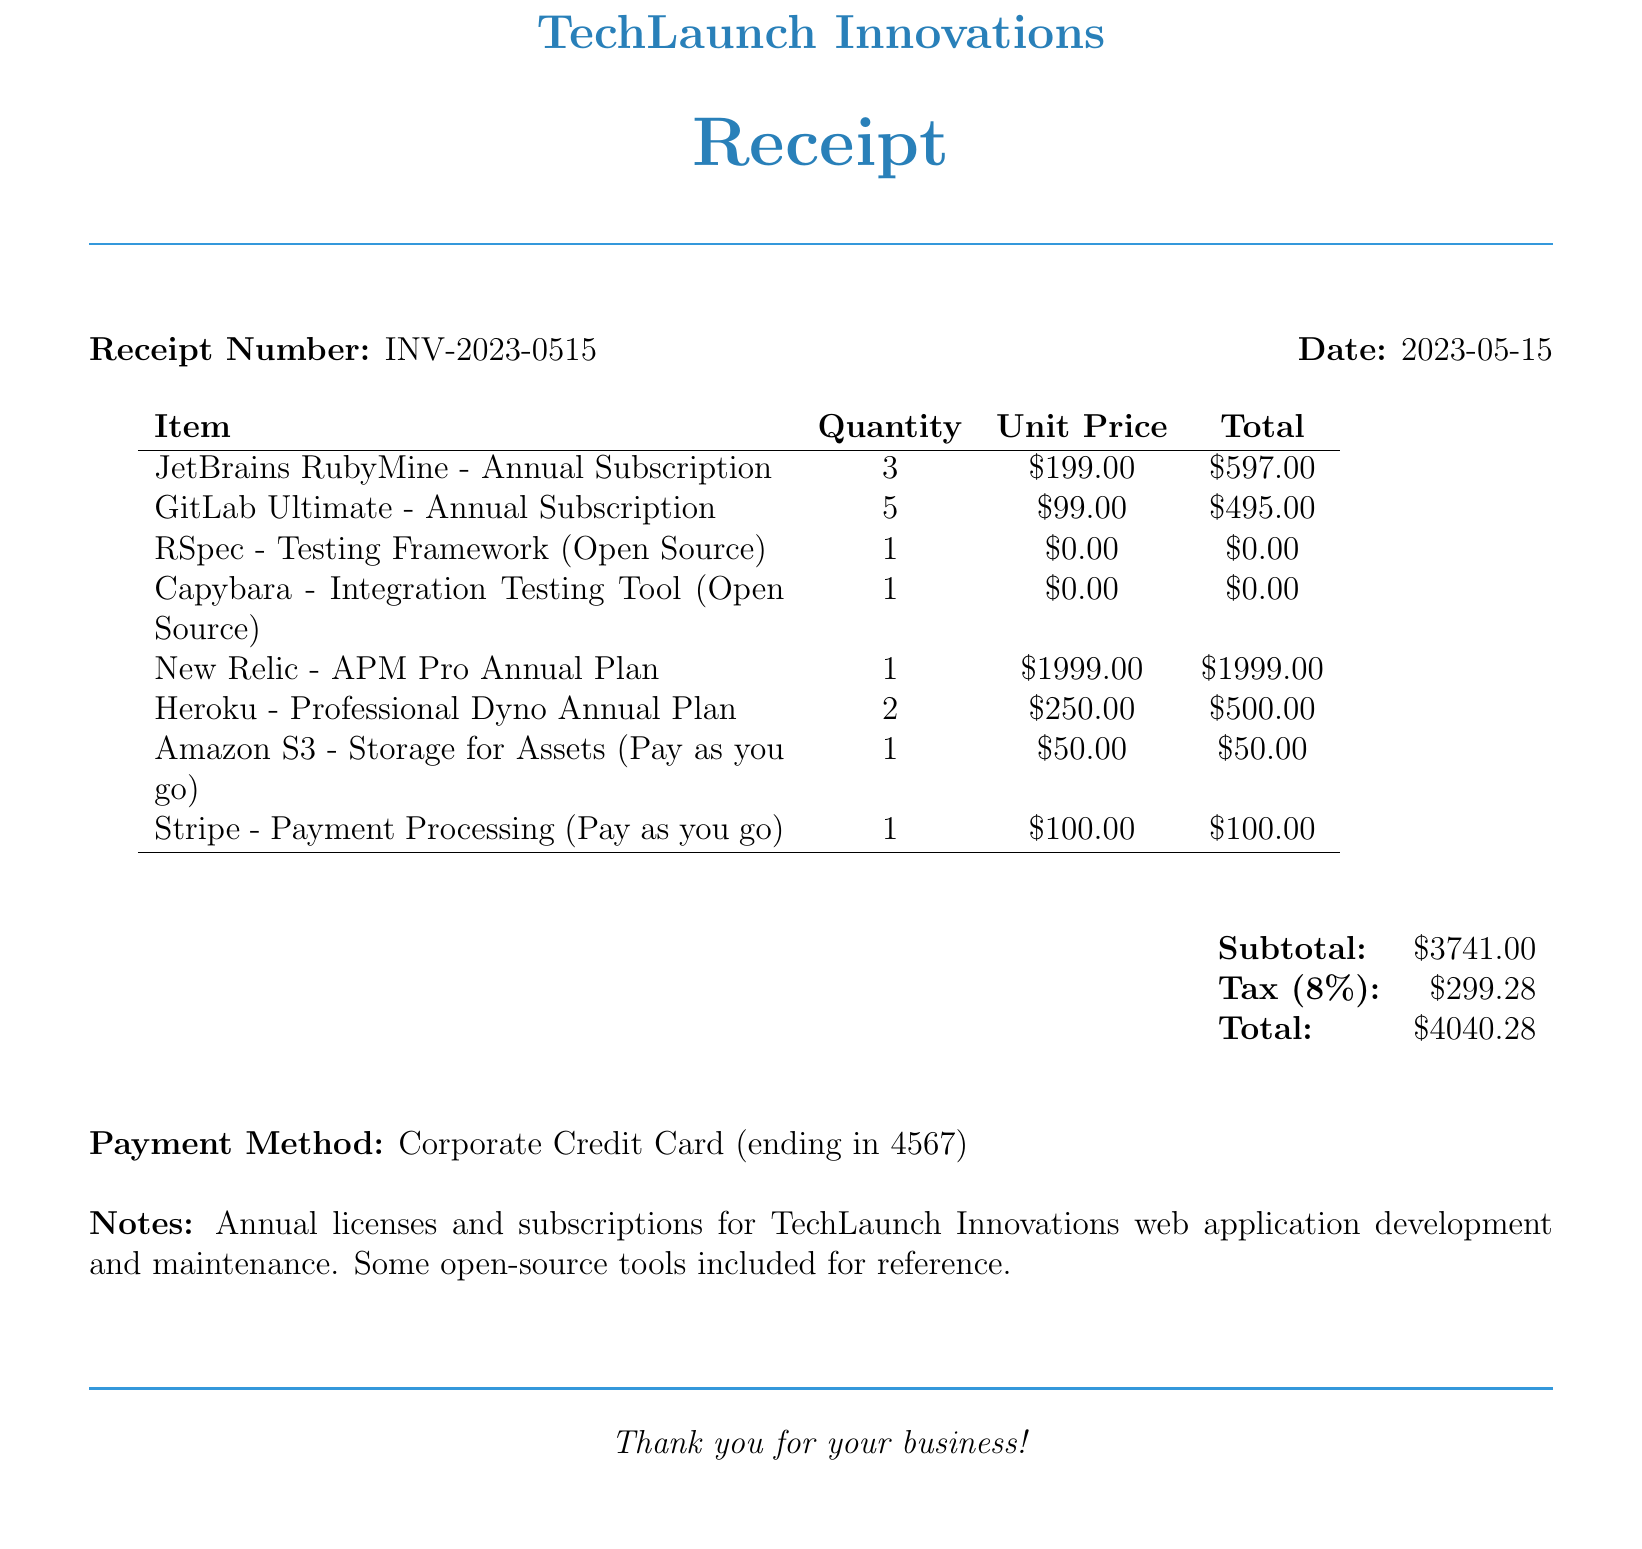what is the company name on the receipt? The company name is listed at the top of the receipt as TechLaunch Innovations.
Answer: TechLaunch Innovations what is the date of the receipt? The receipt date is mentioned alongside the receipt number, which is 2023-05-15.
Answer: 2023-05-15 how many JetBrains RubyMine subscriptions were purchased? The receipt specifies a quantity of JetBrains RubyMine subscriptions purchased, which is listed as 3.
Answer: 3 what is the total amount for the GitLab Ultimate subscription? The total amount for the GitLab Ultimate subscription can be found in the itemized list, which shows $495.00.
Answer: $495.00 what is the subtotal before tax? The subtotal is stated in the summary section of the receipt, which is $3741.00.
Answer: $3741.00 how much is the tax amount? The tax amount is indicated as $299.28, calculated based on the subtotal.
Answer: $299.28 what payment method was used for this receipt? The payment method used is detailed as Corporate Credit Card in the receipt's payment section.
Answer: Corporate Credit Card how much was spent on open source tools? The total cost for the open-source tools, RSpec and Capybara, is indicated as $0.00 in the total column.
Answer: $0.00 what is the receipt number? The receipt number is highlighted on the receipt and is noted as INV-2023-0515.
Answer: INV-2023-0515 